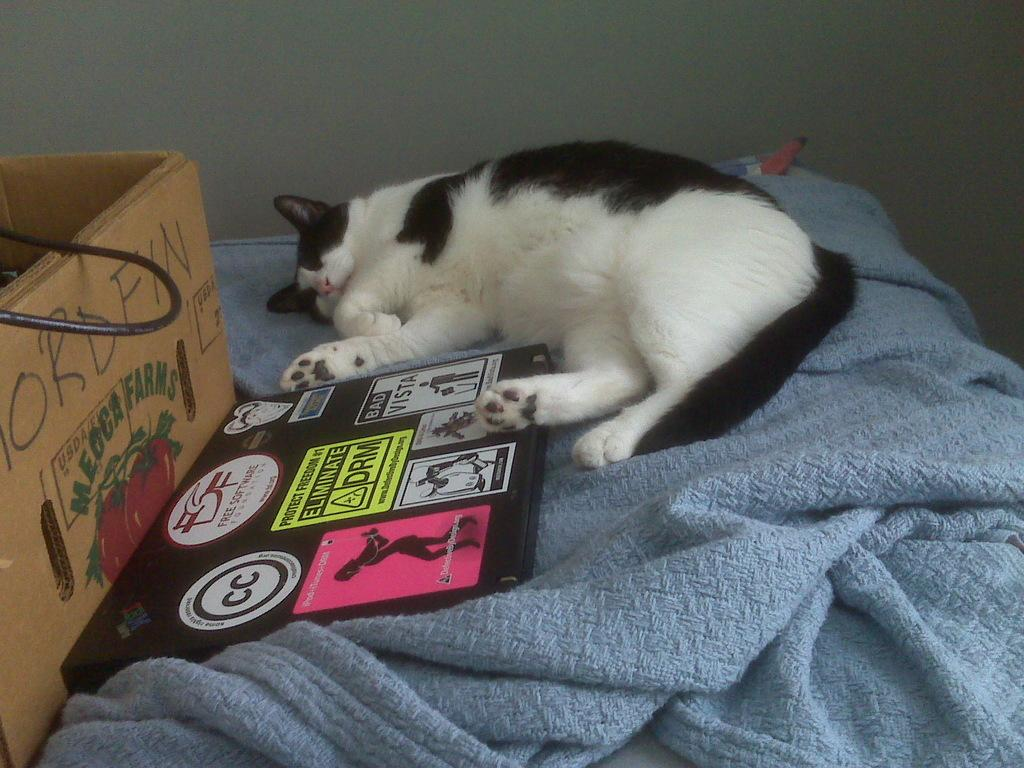<image>
Describe the image concisely. A cat sleeping on a bed next to a box from Meoca Farms. 